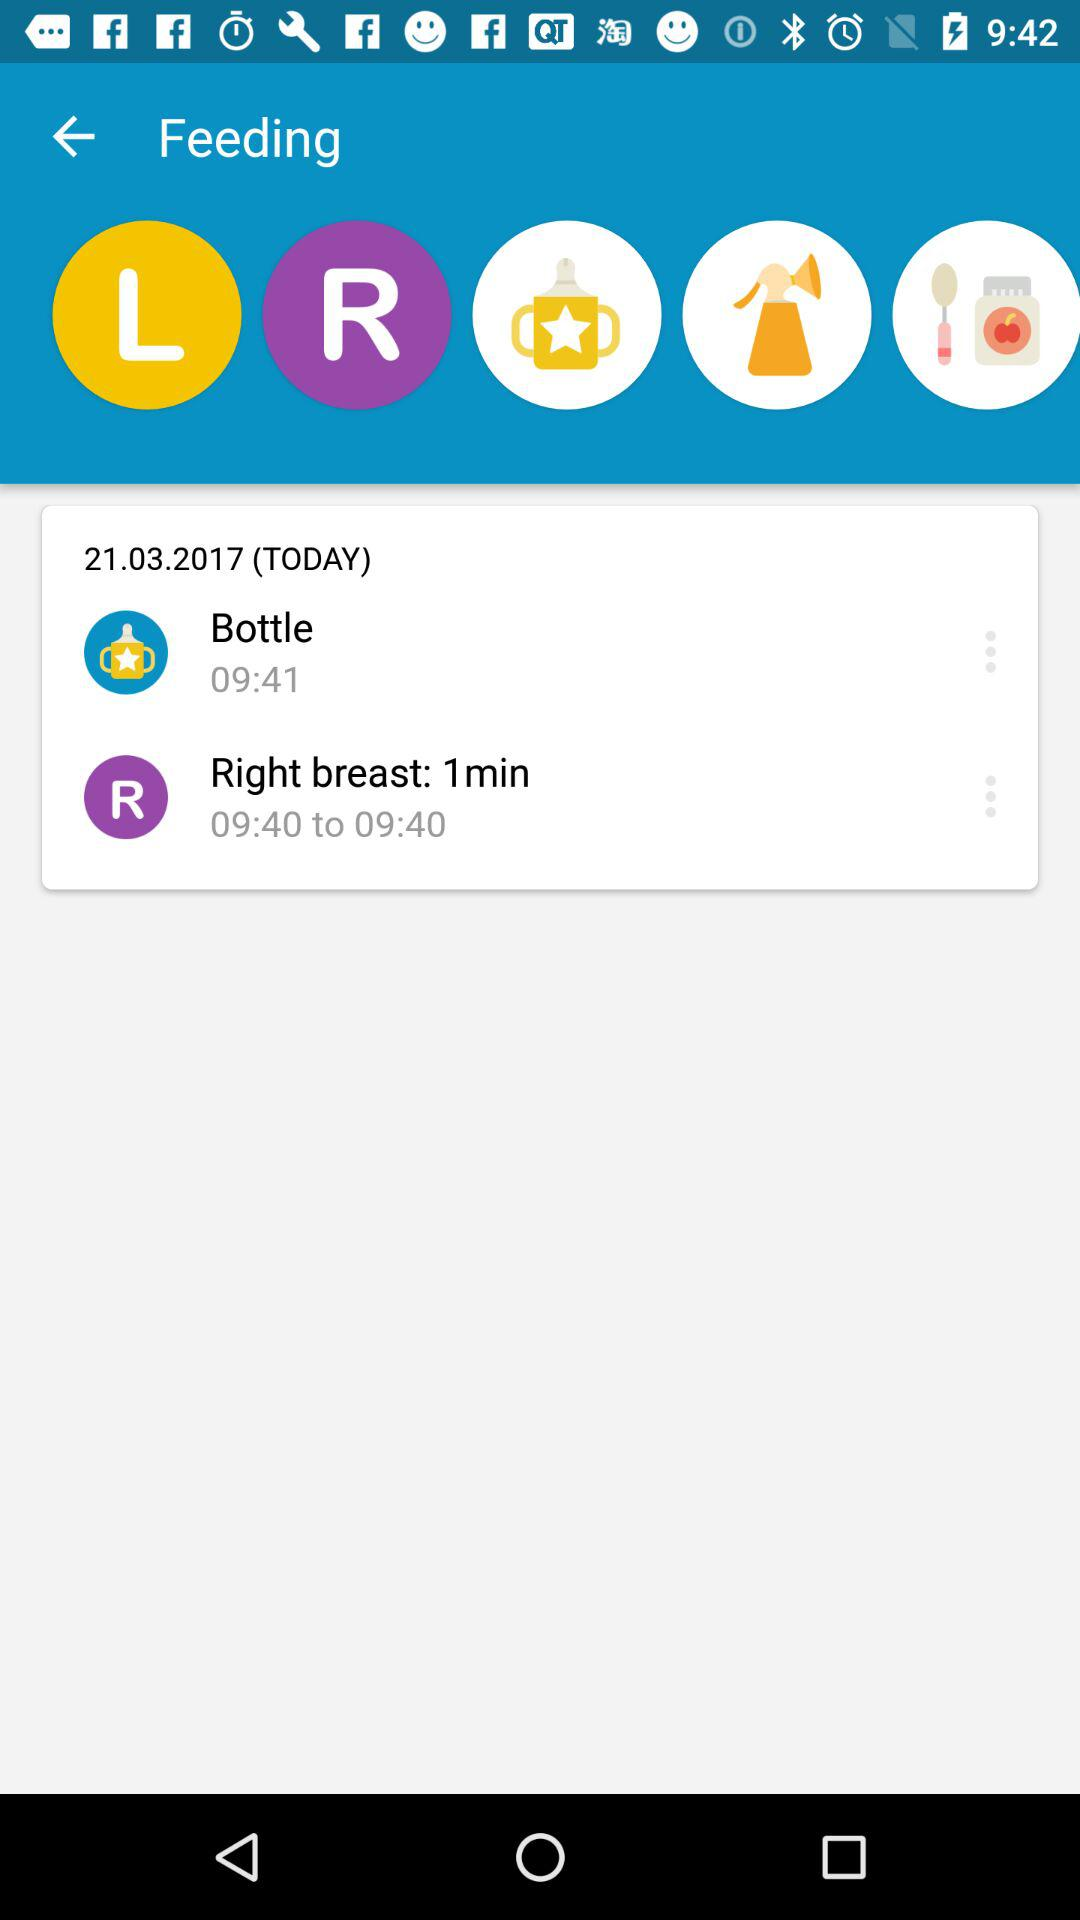How long should the right breast be fed? The right breast should be fed for 1 minute. 